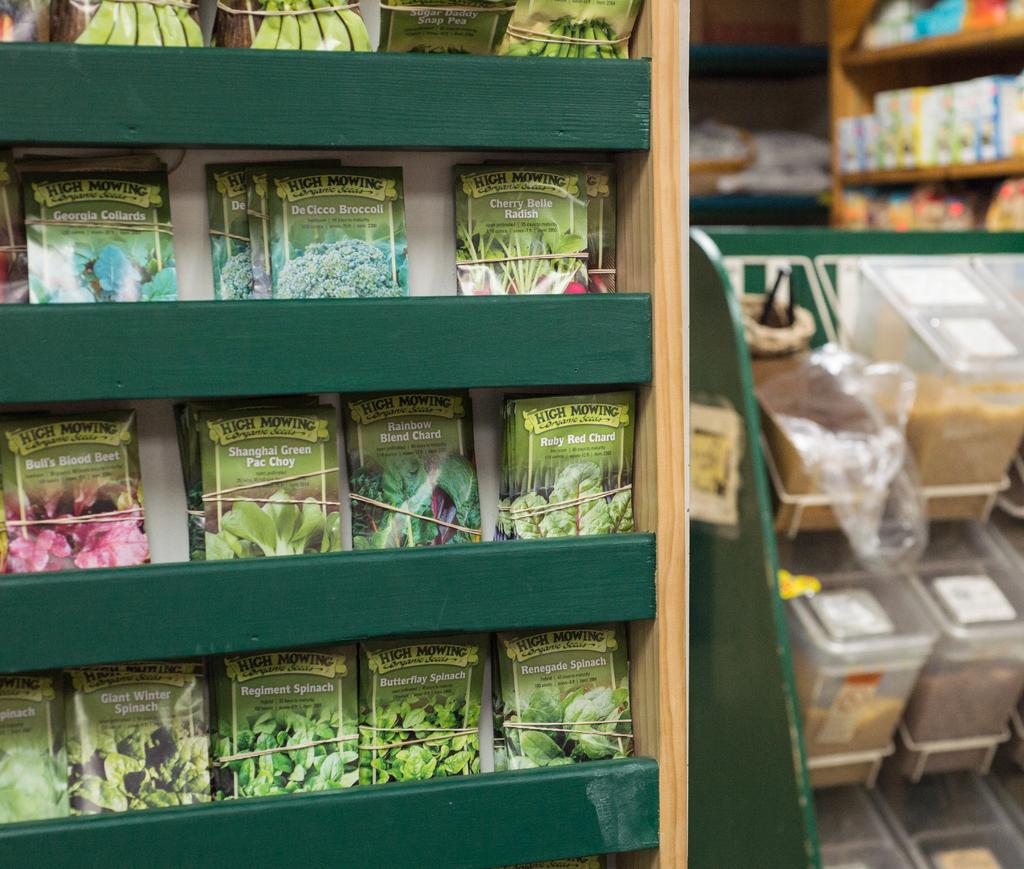Are these organic products?
Offer a terse response. Yes. What brand is shown on the seed packaging?
Your answer should be very brief. High mowing. 